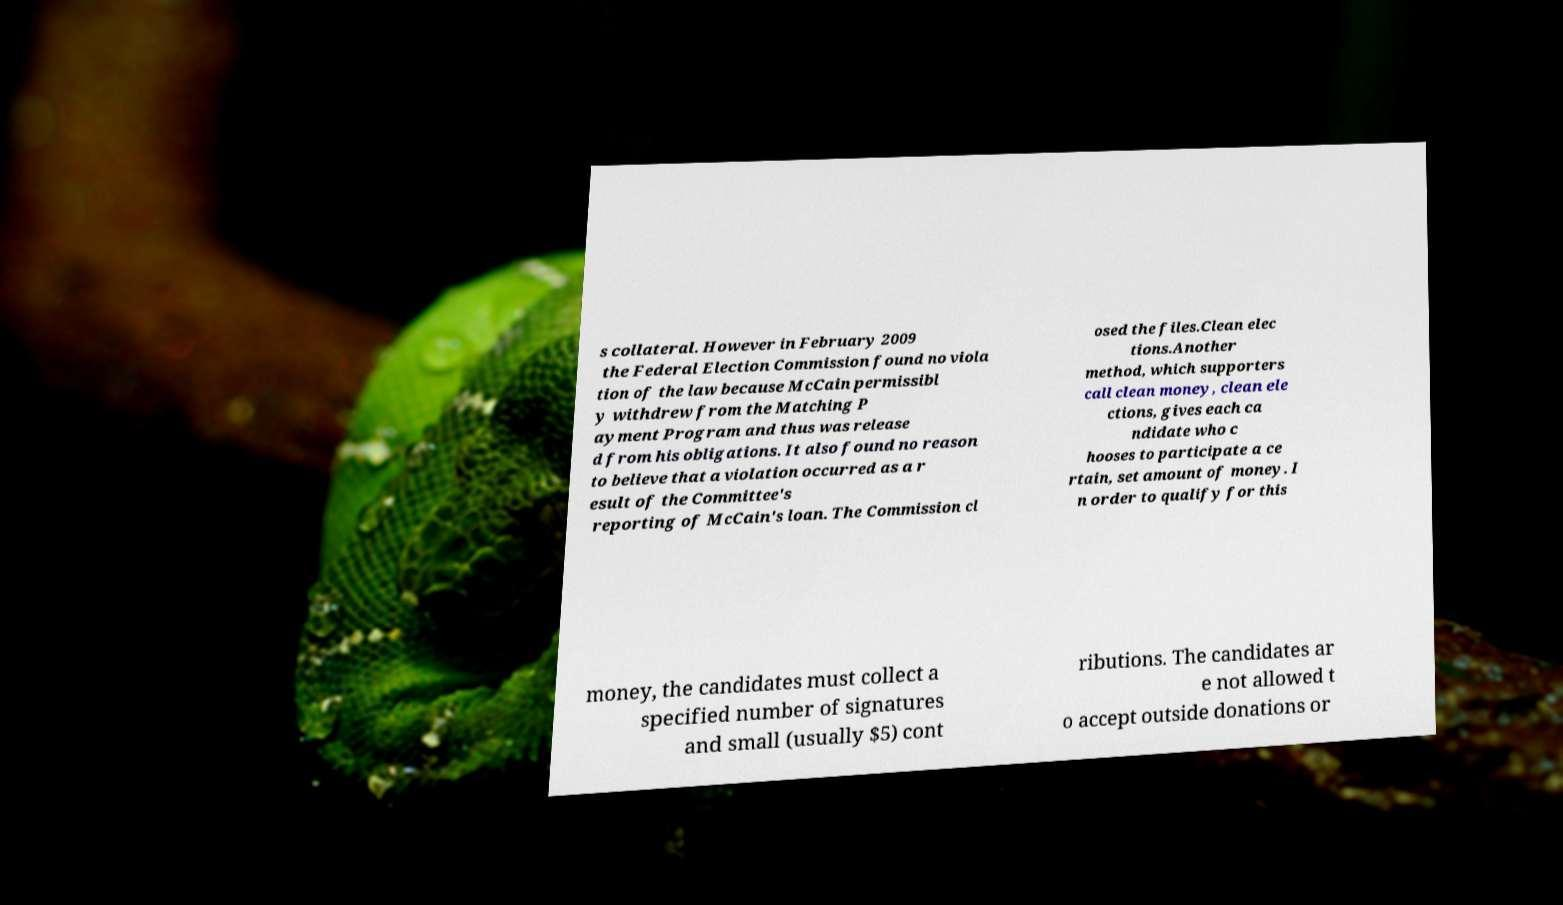I need the written content from this picture converted into text. Can you do that? s collateral. However in February 2009 the Federal Election Commission found no viola tion of the law because McCain permissibl y withdrew from the Matching P ayment Program and thus was release d from his obligations. It also found no reason to believe that a violation occurred as a r esult of the Committee's reporting of McCain's loan. The Commission cl osed the files.Clean elec tions.Another method, which supporters call clean money, clean ele ctions, gives each ca ndidate who c hooses to participate a ce rtain, set amount of money. I n order to qualify for this money, the candidates must collect a specified number of signatures and small (usually $5) cont ributions. The candidates ar e not allowed t o accept outside donations or 